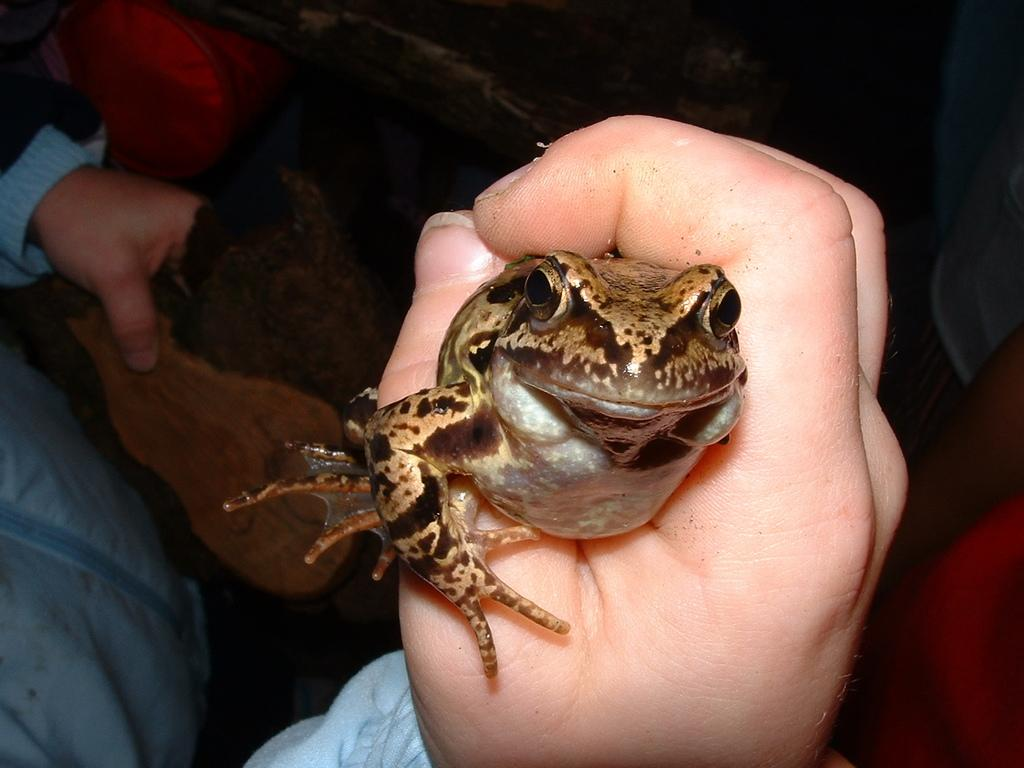What is the main subject of the image? There is a person in the image. What is the person holding in the image? The person is holding a frog. What can be seen on the person's clothing in the image? The person is wearing a blue jacket. What type of hook is the person using to catch fish in the image? There is no hook or fishing activity present in the image; the person is holding a frog. 